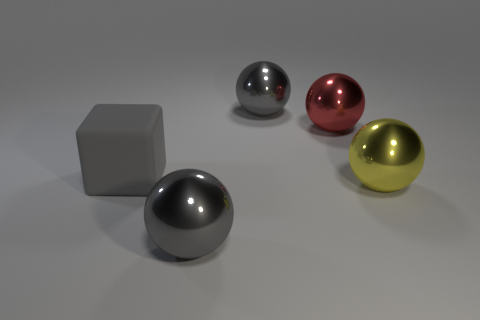Subtract all cyan spheres. Subtract all yellow cylinders. How many spheres are left? 4 Add 3 big gray spheres. How many objects exist? 8 Subtract all blocks. How many objects are left? 4 Add 5 large yellow balls. How many large yellow balls are left? 6 Add 2 tiny red metallic objects. How many tiny red metallic objects exist? 2 Subtract 0 brown balls. How many objects are left? 5 Subtract all shiny things. Subtract all tiny red cubes. How many objects are left? 1 